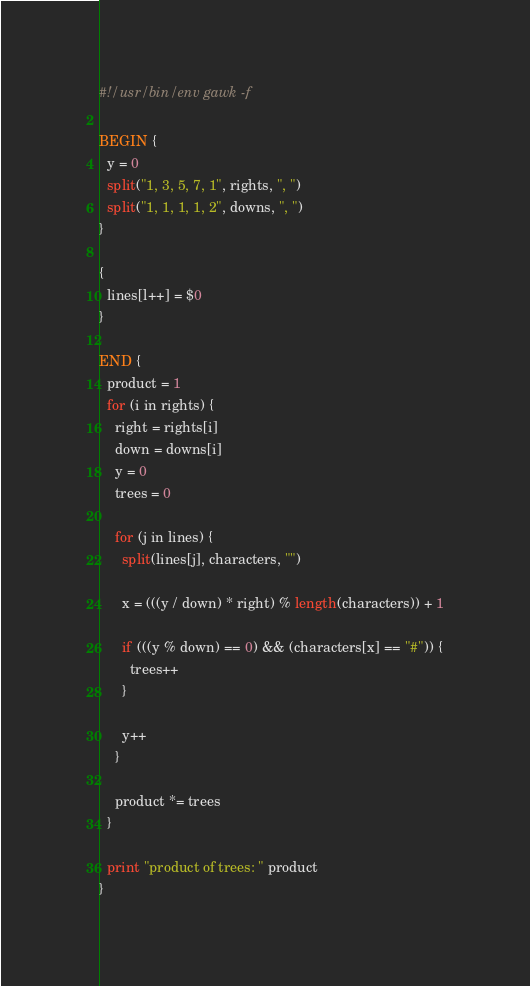Convert code to text. <code><loc_0><loc_0><loc_500><loc_500><_Awk_>#!/usr/bin/env gawk -f

BEGIN {
  y = 0
  split("1, 3, 5, 7, 1", rights, ", ")
  split("1, 1, 1, 1, 2", downs, ", ")
}

{
  lines[l++] = $0
}

END {
  product = 1
  for (i in rights) {
    right = rights[i]
    down = downs[i]
    y = 0
    trees = 0

    for (j in lines) {
      split(lines[j], characters, "")

      x = (((y / down) * right) % length(characters)) + 1

      if (((y % down) == 0) && (characters[x] == "#")) {
        trees++
      }

      y++
    }

    product *= trees
  }

  print "product of trees: " product
}</code> 